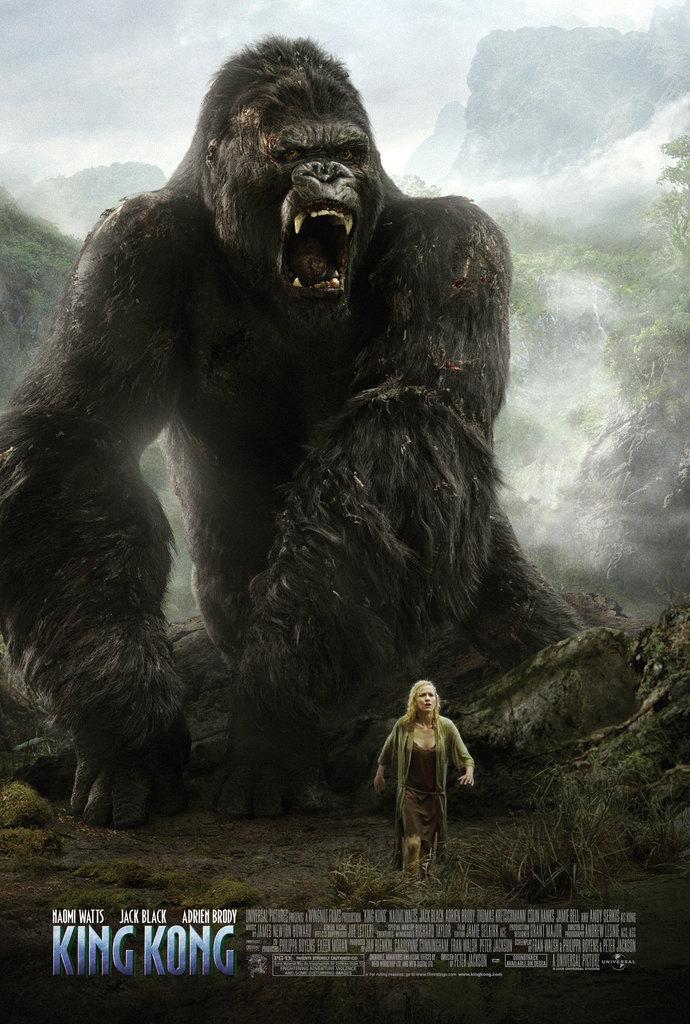In one or two sentences, can you explain what this image depicts? This is image is a movie poster in which there is a gorilla. There is a woman. 